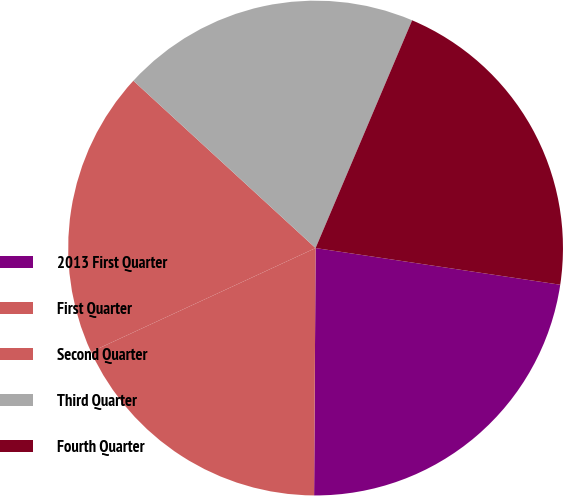Convert chart to OTSL. <chart><loc_0><loc_0><loc_500><loc_500><pie_chart><fcel>2013 First Quarter<fcel>First Quarter<fcel>Second Quarter<fcel>Third Quarter<fcel>Fourth Quarter<nl><fcel>22.73%<fcel>18.01%<fcel>18.72%<fcel>19.56%<fcel>20.99%<nl></chart> 